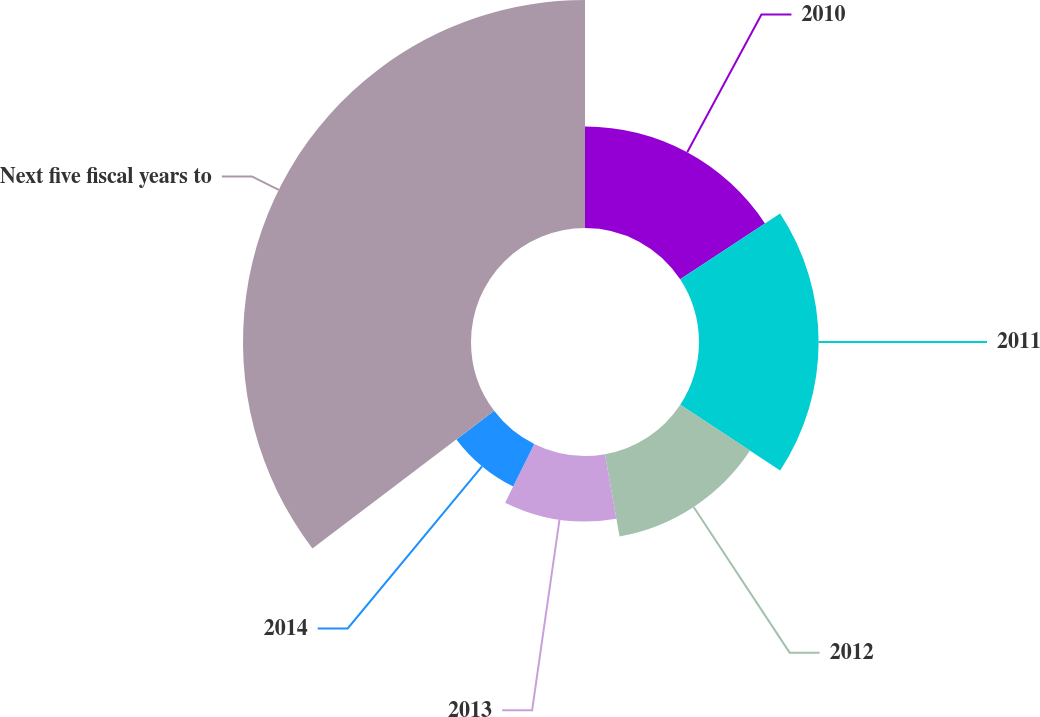Convert chart to OTSL. <chart><loc_0><loc_0><loc_500><loc_500><pie_chart><fcel>2010<fcel>2011<fcel>2012<fcel>2013<fcel>2014<fcel>Next five fiscal years to<nl><fcel>15.73%<fcel>18.53%<fcel>12.94%<fcel>10.14%<fcel>7.34%<fcel>35.32%<nl></chart> 